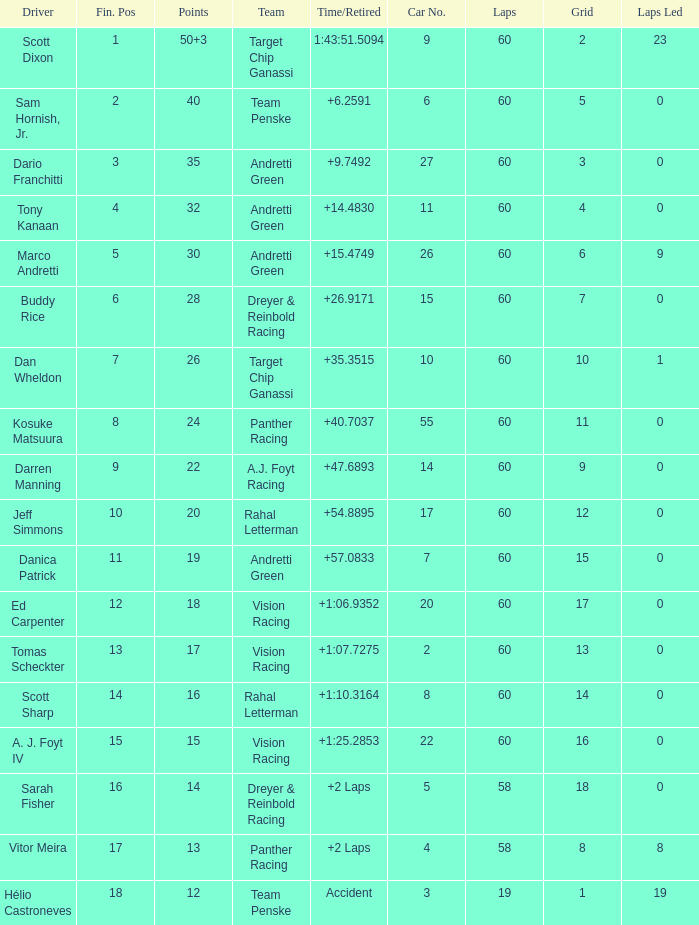Name the team for scott dixon Target Chip Ganassi. 